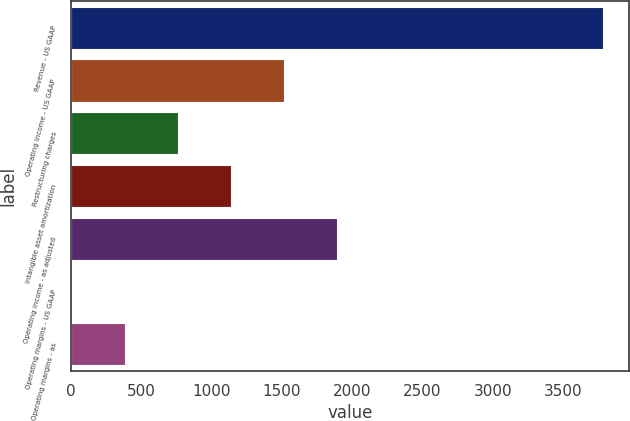Convert chart. <chart><loc_0><loc_0><loc_500><loc_500><bar_chart><fcel>Revenue - US GAAP<fcel>Operating income - US GAAP<fcel>Restructuring charges<fcel>Intangible asset amortization<fcel>Operating income - as adjusted<fcel>Operating margins - US GAAP<fcel>Operating margins - as<nl><fcel>3781<fcel>1517.74<fcel>763.32<fcel>1140.53<fcel>1894.95<fcel>8.9<fcel>386.11<nl></chart> 